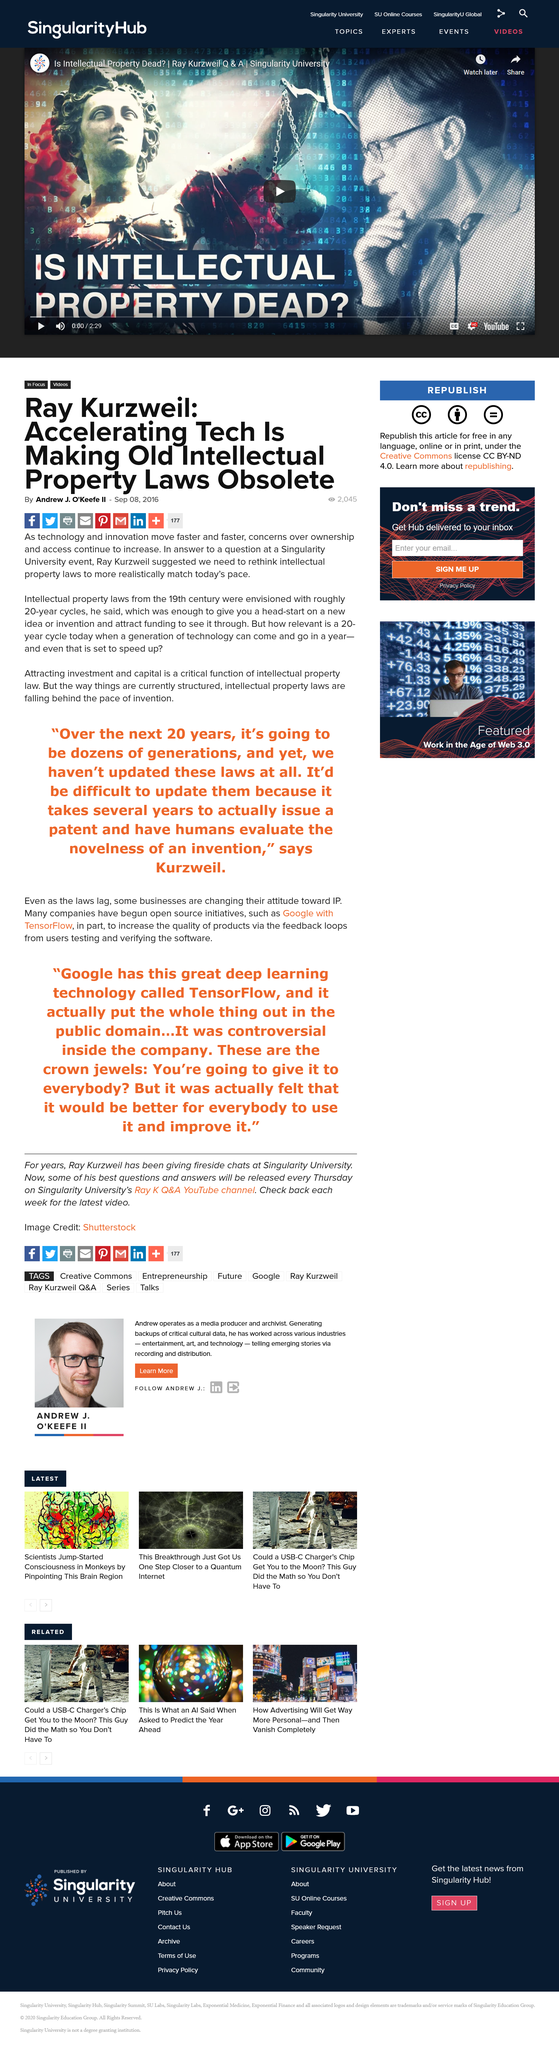Point out several critical features in this image. The article was created on September 08, 2016. Yes, it is shareable on Facebook. The article "Ray Kurzweil: Accelerating Tech is Making Old Intellectual Property Laws Obsolete" was written by Andrew J. O'Keefe II. 